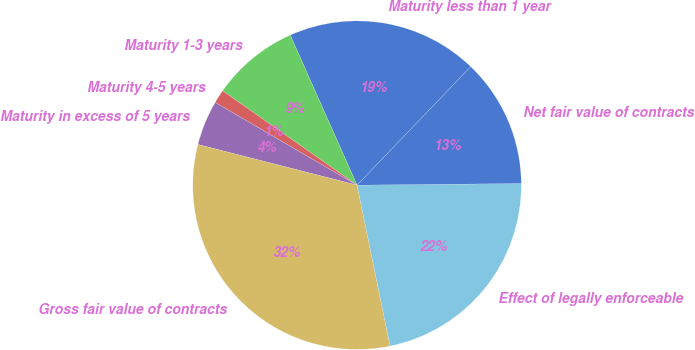Convert chart to OTSL. <chart><loc_0><loc_0><loc_500><loc_500><pie_chart><fcel>Maturity less than 1 year<fcel>Maturity 1-3 years<fcel>Maturity 4-5 years<fcel>Maturity in excess of 5 years<fcel>Gross fair value of contracts<fcel>Effect of legally enforceable<fcel>Net fair value of contracts<nl><fcel>18.84%<fcel>8.59%<fcel>1.34%<fcel>4.42%<fcel>32.21%<fcel>21.93%<fcel>12.67%<nl></chart> 